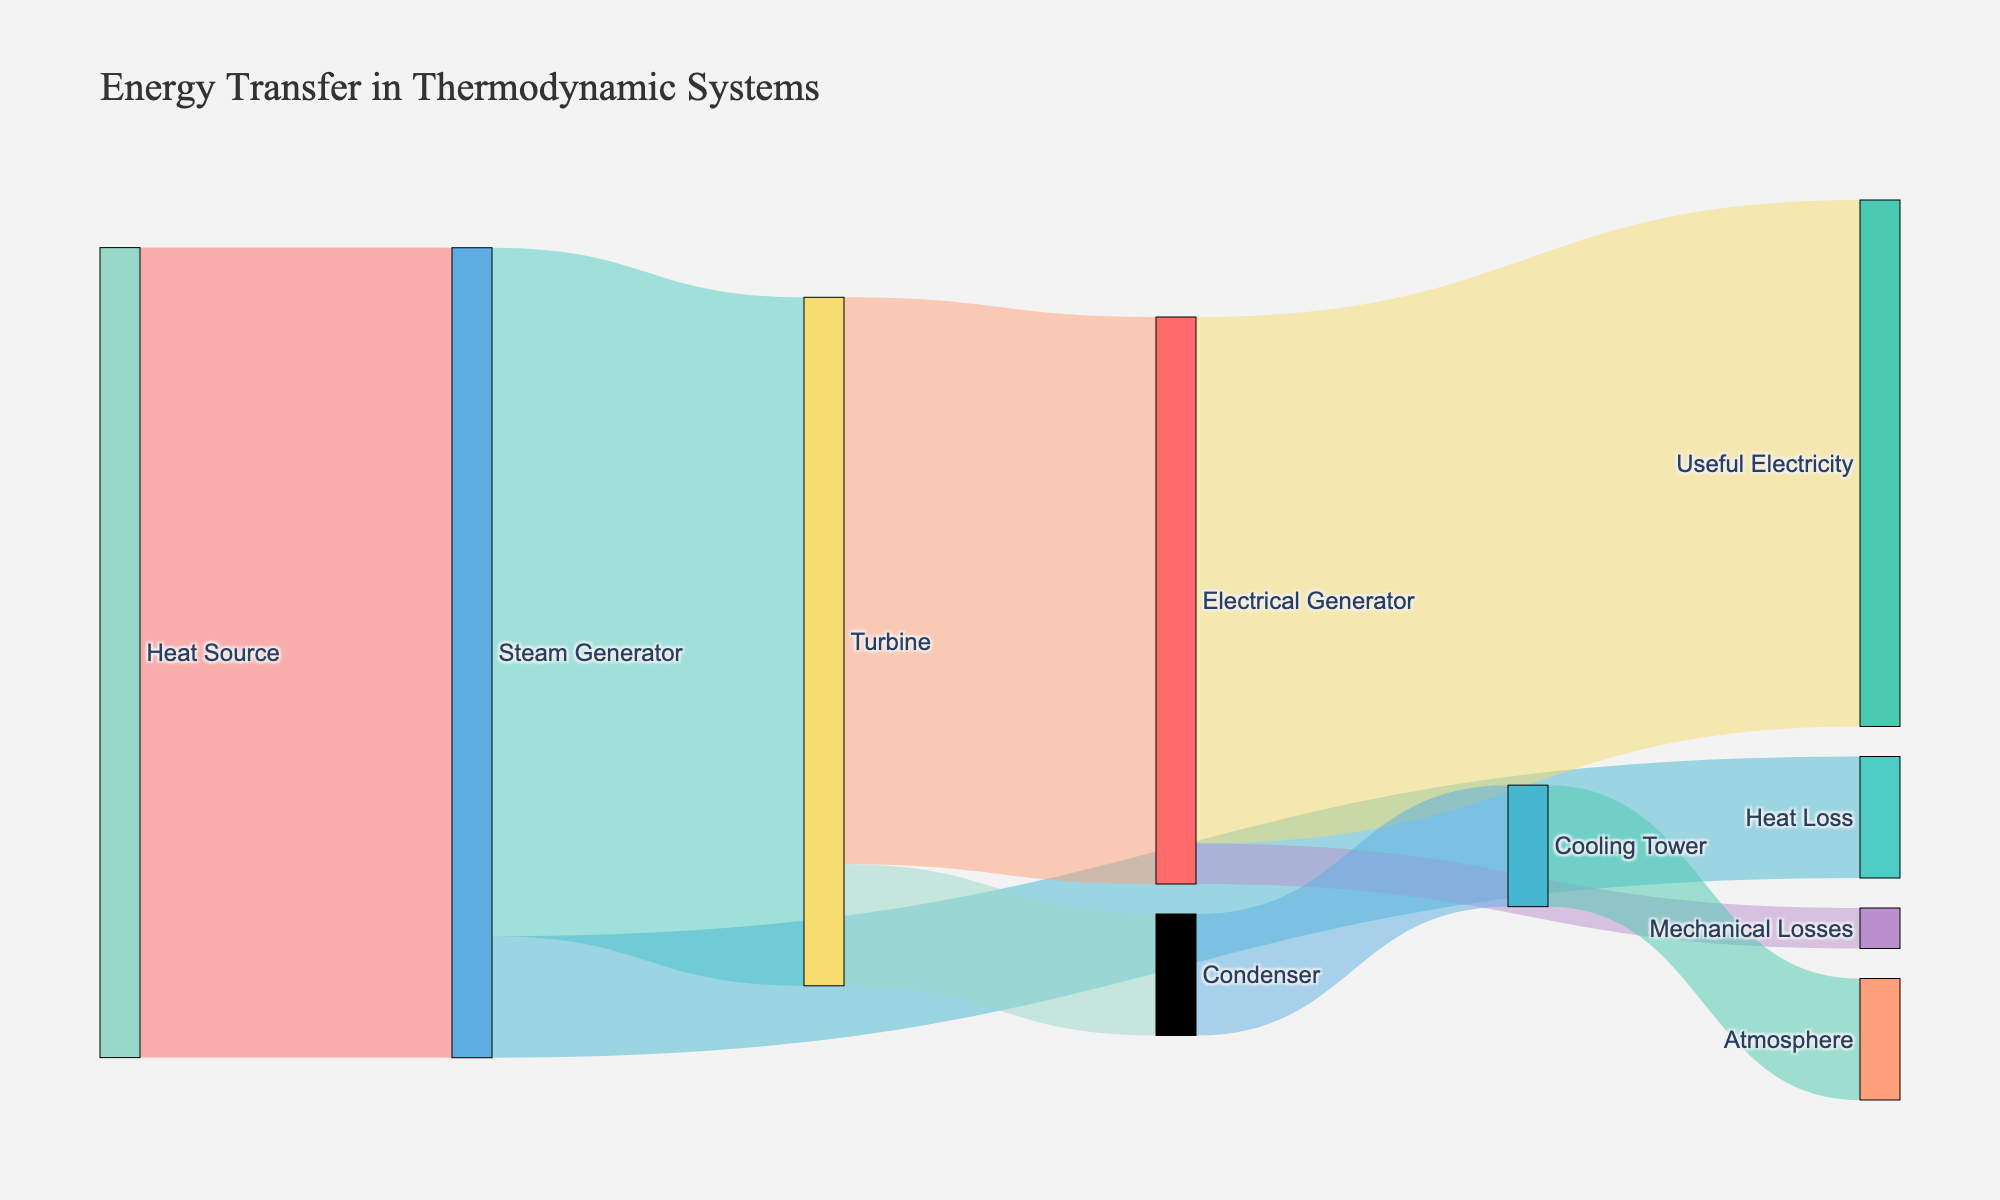What's the title of the Sankey diagram? The title is generally located at the top of the figure and states the main topic of the diagram. Here, it states "Energy Transfer in Thermodynamic Systems".
Answer: Energy Transfer in Thermodynamic Systems How much energy does the Heat Source transfer to the Steam Generator? Look at the link that connects the Heat Source to the Steam Generator. The value listed on this link is the amount of energy transferred. In this case, it's 100 units.
Answer: 100 units What is the total energy loss from the Steam Generator? First identify all the outgoing links from the Steam Generator. There are two: one to the Turbine (85 units) and one to Heat Loss (15 units). The total loss is the sum of these values, which is 15 units.
Answer: 15 units How much energy is converted into useful electricity by the Electrical Generator? Find the link that connects the Electrical Generator to Useful Electricity. The value listed on this link represents the amount of energy converted into useful electricity. It's 65 units.
Answer: 65 units Compare the energy transferred from the Turbine to the Electrical Generator with the energy transferred from the Turbine to the Condenser. The values on the links from the Turbine to the Electrical Generator and the Turbine to the Condenser are 70 units and 15 units, respectively. So, the Turbine transfers more energy to the Electrical Generator.
Answer: 70 units vs. 15 units Which component transfers energy to the atmosphere and how much? Identify the component that transfers energy to the atmosphere by following the flow in the diagram. The Cooling Tower transfers 15 units to the atmosphere.
Answer: Cooling Tower, 15 units What is the energy efficiency of the Steam Generator? The efficiency can be calculated by considering how much energy was transferred to the Turbine (85 units) from the Steam Generator, out of the total input energy from the Heat Source (100 units). Efficiency = (85 / 100) * 100%.
Answer: 85% Calculate the total mechanical losses in the system. Find the flow of mechanical losses. Electrical Generator to Mechanical Losses is 5 units. Therefore, total mechanical losses are 5 units.
Answer: 5 units Determine the energy left after mechanical losses by the Electrical Generator. Subtract the mechanical losses (5 units) from the energy transferred from Electrical Generator to Useful Electricity (65 units). Energy left = 65 - 5 = 60 units.
Answer: 60 units Identify all the points where energy is lost in the system. Energy is lost at several points: Steam Generator to Heat Loss (15 units), Turbine to Condenser (15 units), and Electrical Generator to Mechanical Losses (5 units). Overall, the points are Heat Loss, Condenser, and Mechanical Losses.
Answer: Heat Loss, Condenser, Mechanical Losses 